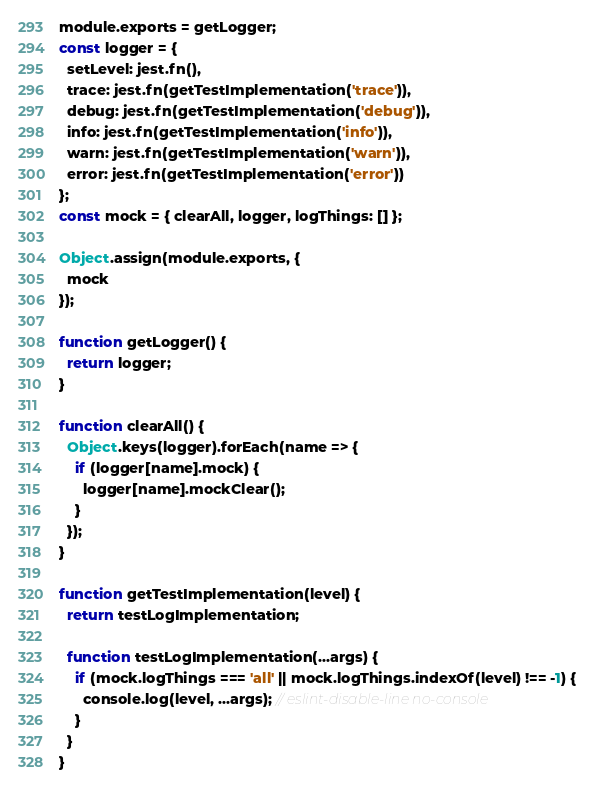<code> <loc_0><loc_0><loc_500><loc_500><_JavaScript_>module.exports = getLogger;
const logger = {
  setLevel: jest.fn(),
  trace: jest.fn(getTestImplementation('trace')),
  debug: jest.fn(getTestImplementation('debug')),
  info: jest.fn(getTestImplementation('info')),
  warn: jest.fn(getTestImplementation('warn')),
  error: jest.fn(getTestImplementation('error'))
};
const mock = { clearAll, logger, logThings: [] };

Object.assign(module.exports, {
  mock
});

function getLogger() {
  return logger;
}

function clearAll() {
  Object.keys(logger).forEach(name => {
    if (logger[name].mock) {
      logger[name].mockClear();
    }
  });
}

function getTestImplementation(level) {
  return testLogImplementation;

  function testLogImplementation(...args) {
    if (mock.logThings === 'all' || mock.logThings.indexOf(level) !== -1) {
      console.log(level, ...args); // eslint-disable-line no-console
    }
  }
}
</code> 